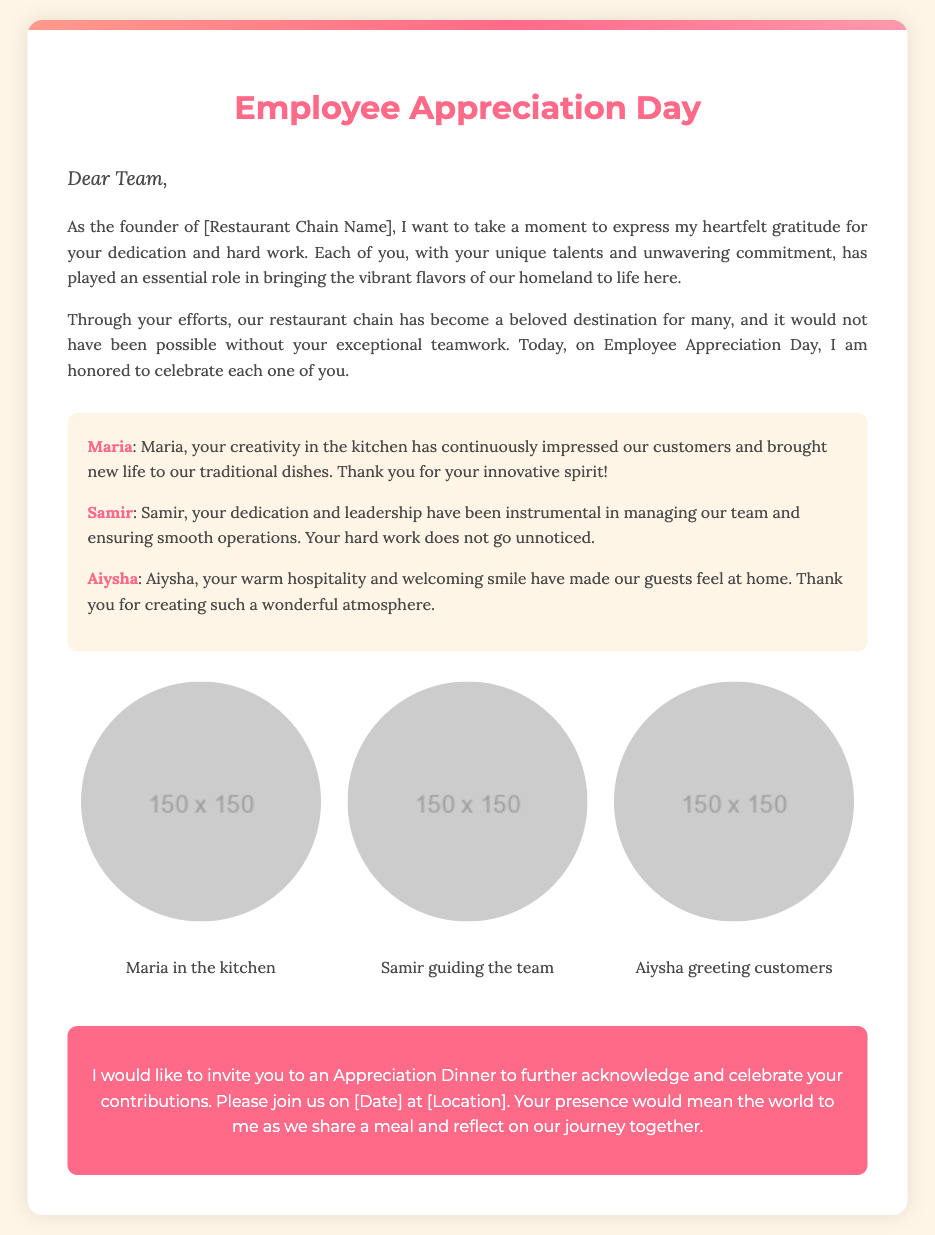What is the title of the card? The title is prominently displayed at the top of the card and indicates the purpose of the document.
Answer: Employee Appreciation Day Who is the card addressed to? The opening salutation indicates the intended recipients of the message.
Answer: Team What is the main purpose of the card? The content describes the initiative behind the card and the emotions expressed within it.
Answer: To express gratitude How many personalized notes are included? The card contains three distinct personalized messages highlighting individual contributions.
Answer: Three What is the name of the employee recognized for their creativity in the kitchen? The specific note highlights an individual's contributions and so names them directly.
Answer: Maria What color is used for the invitation section? The design features a specific color scheme for different sections, including the invitation.
Answer: Pink When is the Appreciation Dinner planned? The invitation includes a placeholder for the date, indicating when the event will occur.
Answer: [Date] What does the employee Samir help manage? The note for Samir mentions his role in relation to team dynamics.
Answer: Operations What will attendees share during the Appreciation Dinner? The invitation hints at the primary activity planned for the dinner event.
Answer: A meal 